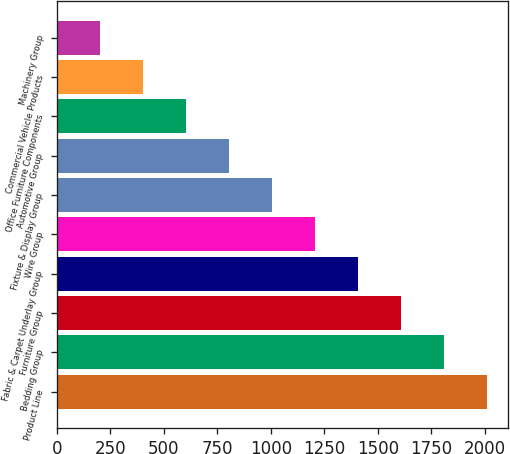<chart> <loc_0><loc_0><loc_500><loc_500><bar_chart><fcel>Product Line<fcel>Bedding Group<fcel>Furniture Group<fcel>Fabric & Carpet Underlay Group<fcel>Wire Group<fcel>Fixture & Display Group<fcel>Automotive Group<fcel>Office Furniture Components<fcel>Commercial Vehicle Products<fcel>Machinery Group<nl><fcel>2009<fcel>1808.3<fcel>1607.6<fcel>1406.9<fcel>1206.2<fcel>1005.5<fcel>804.8<fcel>604.1<fcel>403.4<fcel>202.7<nl></chart> 